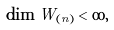<formula> <loc_0><loc_0><loc_500><loc_500>\dim W _ { ( n ) } < \infty ,</formula> 